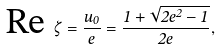<formula> <loc_0><loc_0><loc_500><loc_500>\text {Re} \ \zeta = \frac { u _ { 0 } } { e } = \frac { 1 + \sqrt { 2 e ^ { 2 } - 1 } } { 2 e } ,</formula> 